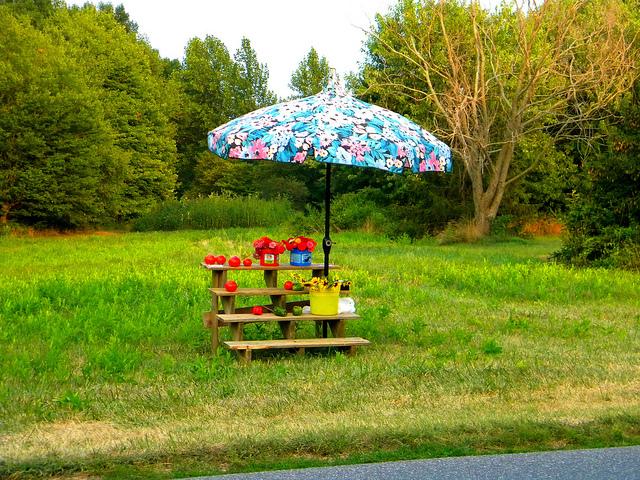What color is the umbrella?
Keep it brief. Floral. Is it a hot day?
Quick response, please. Yes. Is there a chair?
Keep it brief. No. 